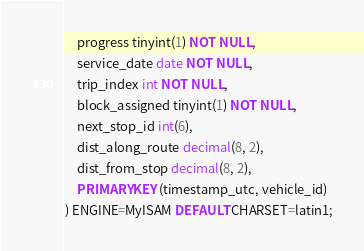Convert code to text. <code><loc_0><loc_0><loc_500><loc_500><_SQL_>	progress tinyint(1) NOT NULL,
	service_date date NOT NULL,
	trip_index int NOT NULL,
	block_assigned tinyint(1) NOT NULL,
	next_stop_id int(6),
	dist_along_route decimal(8, 2),
	dist_from_stop decimal(8, 2),
	PRIMARY KEY (timestamp_utc, vehicle_id)
) ENGINE=MyISAM DEFAULT CHARSET=latin1;

</code> 